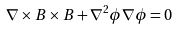Convert formula to latex. <formula><loc_0><loc_0><loc_500><loc_500>\nabla \times { B } \times { B } + \nabla ^ { 2 } \phi \nabla \phi = 0</formula> 